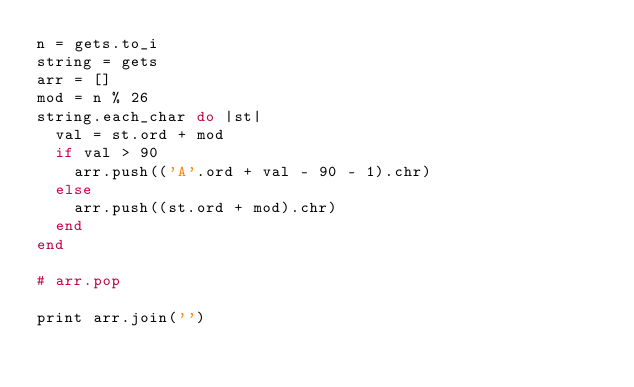Convert code to text. <code><loc_0><loc_0><loc_500><loc_500><_Ruby_>n = gets.to_i
string = gets
arr = []
mod = n % 26
string.each_char do |st|
  val = st.ord + mod
  if val > 90
    arr.push(('A'.ord + val - 90 - 1).chr)
  else
    arr.push((st.ord + mod).chr)
  end
end

# arr.pop

print arr.join('')</code> 